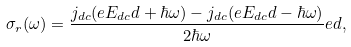<formula> <loc_0><loc_0><loc_500><loc_500>\sigma _ { r } ( \omega ) = \frac { j _ { d c } ( e E _ { d c } d + \hbar { \omega } ) - j _ { d c } ( e E _ { d c } d - \hbar { \omega } ) } { 2 \hbar { \omega } } e d ,</formula> 